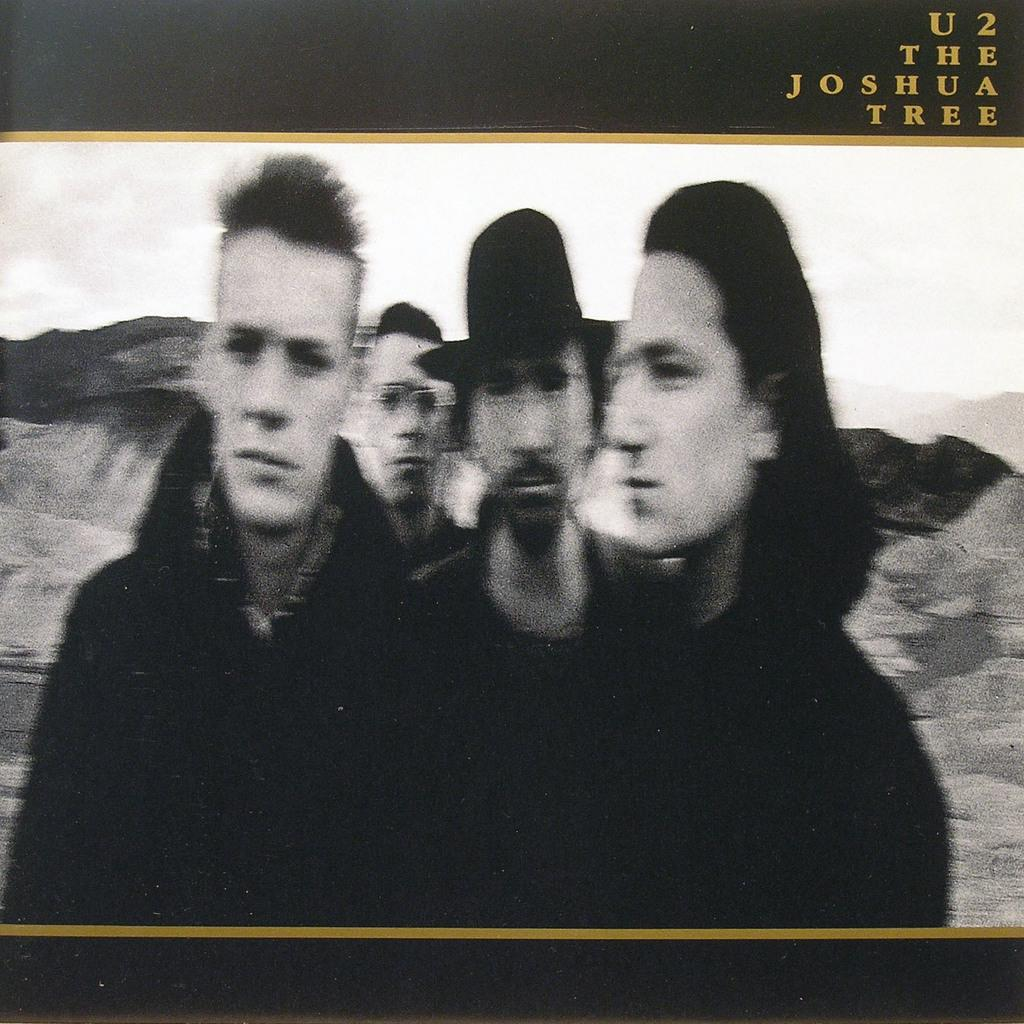What is the color scheme of the image? The image is black and white. What can be seen in the middle of the image? There are four men in the middle of the image. Is there any text present in the image? Yes, there is some text on the right side top of the image. What type of letters does the aunt send to the men in the image? There is no aunt or letters present in the image. 